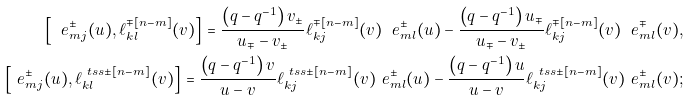Convert formula to latex. <formula><loc_0><loc_0><loc_500><loc_500>\left [ \ e ^ { \pm } _ { m j } ( u ) , \ell ^ { \mp [ n - m ] } _ { k l } ( v ) \right ] = \frac { \left ( q - q ^ { - 1 } \right ) v _ { \pm } } { u _ { \mp } - v _ { \pm } } \ell ^ { \mp [ n - m ] } _ { k j } ( v ) \ e ^ { \pm } _ { m l } ( u ) - \frac { \left ( q - q ^ { - 1 } \right ) u _ { \mp } } { u _ { \mp } - v _ { \pm } } \ell ^ { \mp [ n - m ] } _ { k j } ( v ) \ e ^ { \mp } _ { m l } ( v ) , \\ \left [ \ e ^ { \pm } _ { m j } ( u ) , \ell ^ { \ t s s \pm [ n - m ] } _ { k l } ( v ) \right ] = \frac { \left ( q - q ^ { - 1 } \right ) v } { u - v } \ell ^ { \ t s s \pm [ n - m ] } _ { k j } ( v ) \ e ^ { \pm } _ { m l } ( u ) - \frac { \left ( q - q ^ { - 1 } \right ) u } { u - v } \ell ^ { \ t s s \pm [ n - m ] } _ { k j } ( v ) \ e ^ { \pm } _ { m l } ( v ) ;</formula> 